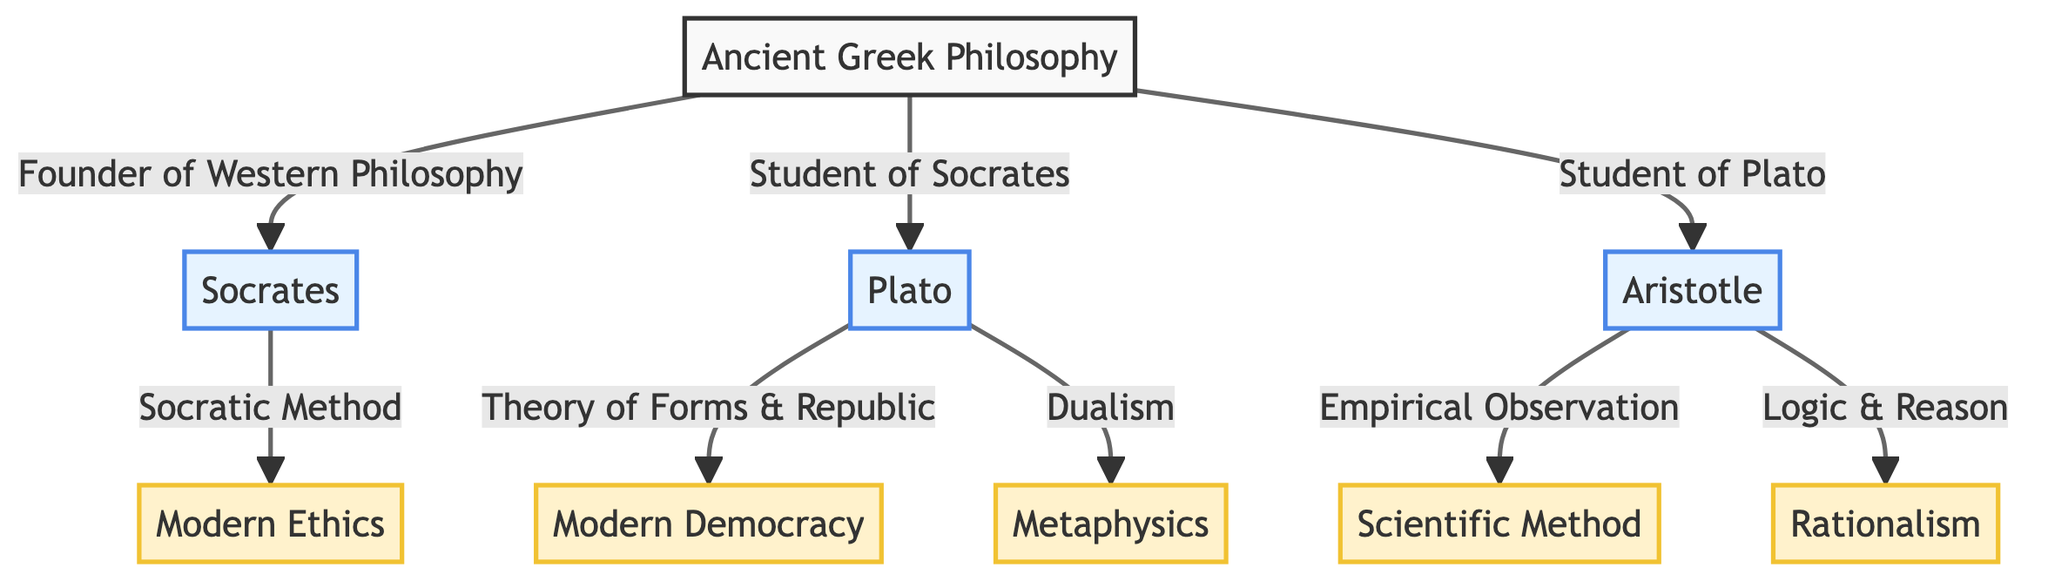What are the three philosophers shown in the diagram? The diagram depicts three philosophers: Socrates, Plato, and Aristotle, connected to Ancient Greek Philosophy.
Answer: Socrates, Plato, Aristotle What concept is linked to Socrates? The diagram indicates that Socrates is connected to Modern Ethics through the Socratic Method.
Answer: Modern Ethics Which philosopher is described as a student of Plato? According to the diagram, Aristotle is recognized as a student of Plato.
Answer: Aristotle How many concepts are influenced by Ancient Greek Philosophy in the diagram? The diagram shows five concepts: Modern Ethics, Modern Democracy, Scientific Method, Metaphysics, and Rationalism. Therefore, there are five concepts.
Answer: 5 What theory of Plato heavily influences Modern Democracy? The diagram states that Plato's Theory of Forms & Republic influences Modern Democracy.
Answer: Theory of Forms & Republic What is the influence of Aristotle on the Scientific Method? The diagram shows that Aristotle's Empirical Observation influences the Scientific Method, indicating his approach to deriving knowledge through observation and experimentation.
Answer: Empirical Observation Which philosophical concept is connected to Aristotle through Logic & Reason? The diagram illustrates that Rationalism is connected to Aristotle through the concept of Logic & Reason.
Answer: Rationalism Which philosophical concept does Plato's Dualism influence? The diagram indicates that Plato's Dualism influences Metaphysics, depicting the relationship between Plato’s philosophical thought and the nature of reality.
Answer: Metaphysics What is the pathway of influence from Ancient Greek Philosophy to Modern Ethics? The diagram describes a pathway where Ancient Greek Philosophy influences Socrates, who further connects to Modern Ethics through the Socratic Method. This illustrates the foundational role of Socrates in shaping ethical thought.
Answer: Socratic Method 